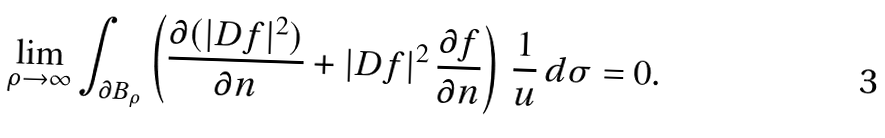Convert formula to latex. <formula><loc_0><loc_0><loc_500><loc_500>\lim _ { \rho \to \infty } \int _ { \partial B _ { \rho } } \left ( \frac { \partial ( | D f | ^ { 2 } ) } { \partial n } + | D f | ^ { 2 } \, \frac { \partial f } { \partial n } \right ) \, \frac { 1 } { u } \, d \sigma = 0 .</formula> 